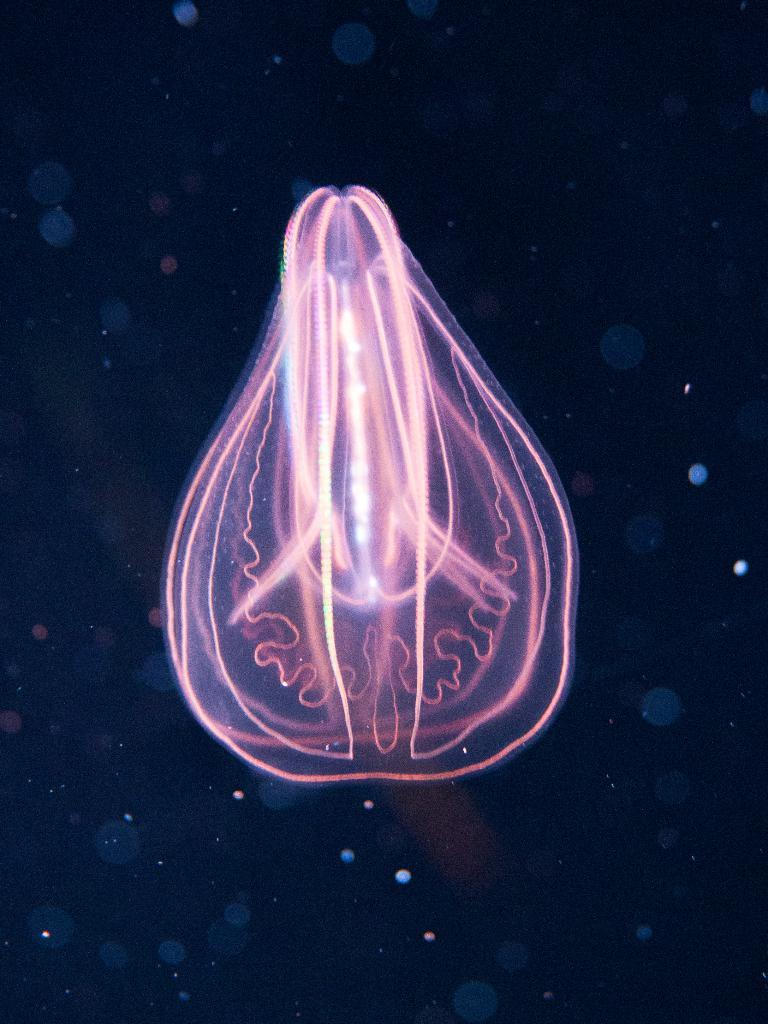What can be said about the nature of the image? The image is edited. What is present in the image? There is an object in the image. What is the color of the object in the image? The object is pink in color. What type of relation is depicted between the babies in the image? There are no babies present in the image, so it is not possible to determine any relation between them. 